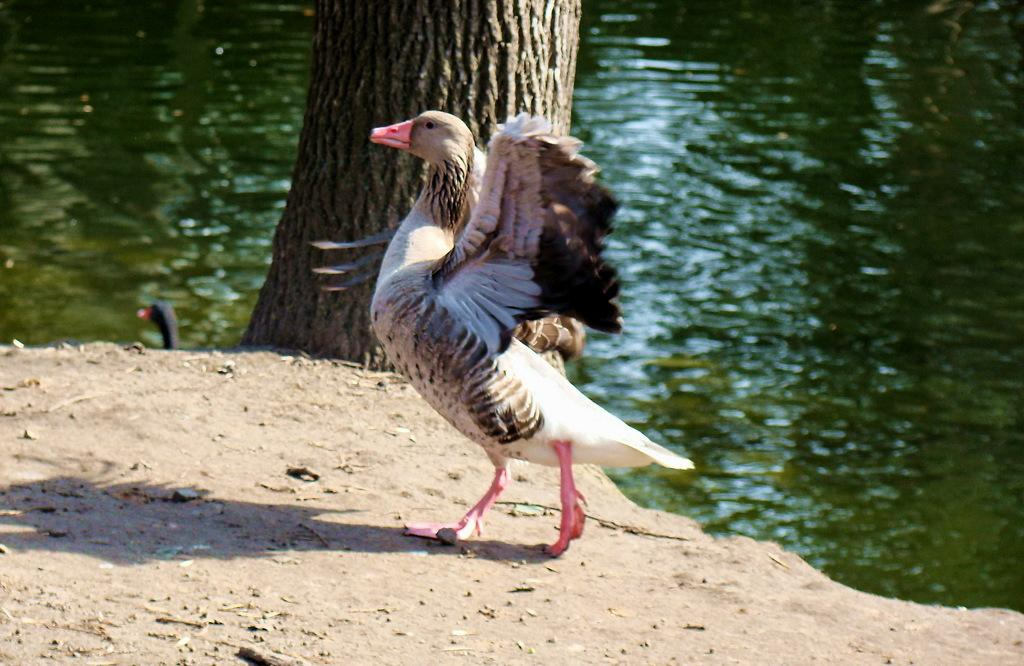What type of animal can be seen in the image? There is a bird in the image. Can you describe the bird's appearance? The bird has brown, black, and white colors. What can be seen in the background of the image? There is a trunk in the background of the image. What is the color of the trunk? The trunk is brown in color. Are there any other birds visible in the image? Yes, there is another bird in the water in the image. What type of food is the bird eating in the image? There is no food visible in the image, so it cannot be determined what the bird might be eating. 